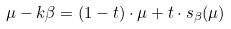<formula> <loc_0><loc_0><loc_500><loc_500>\mu - k \beta = ( 1 - t ) \cdot \mu + t \cdot s _ { \beta } ( \mu )</formula> 